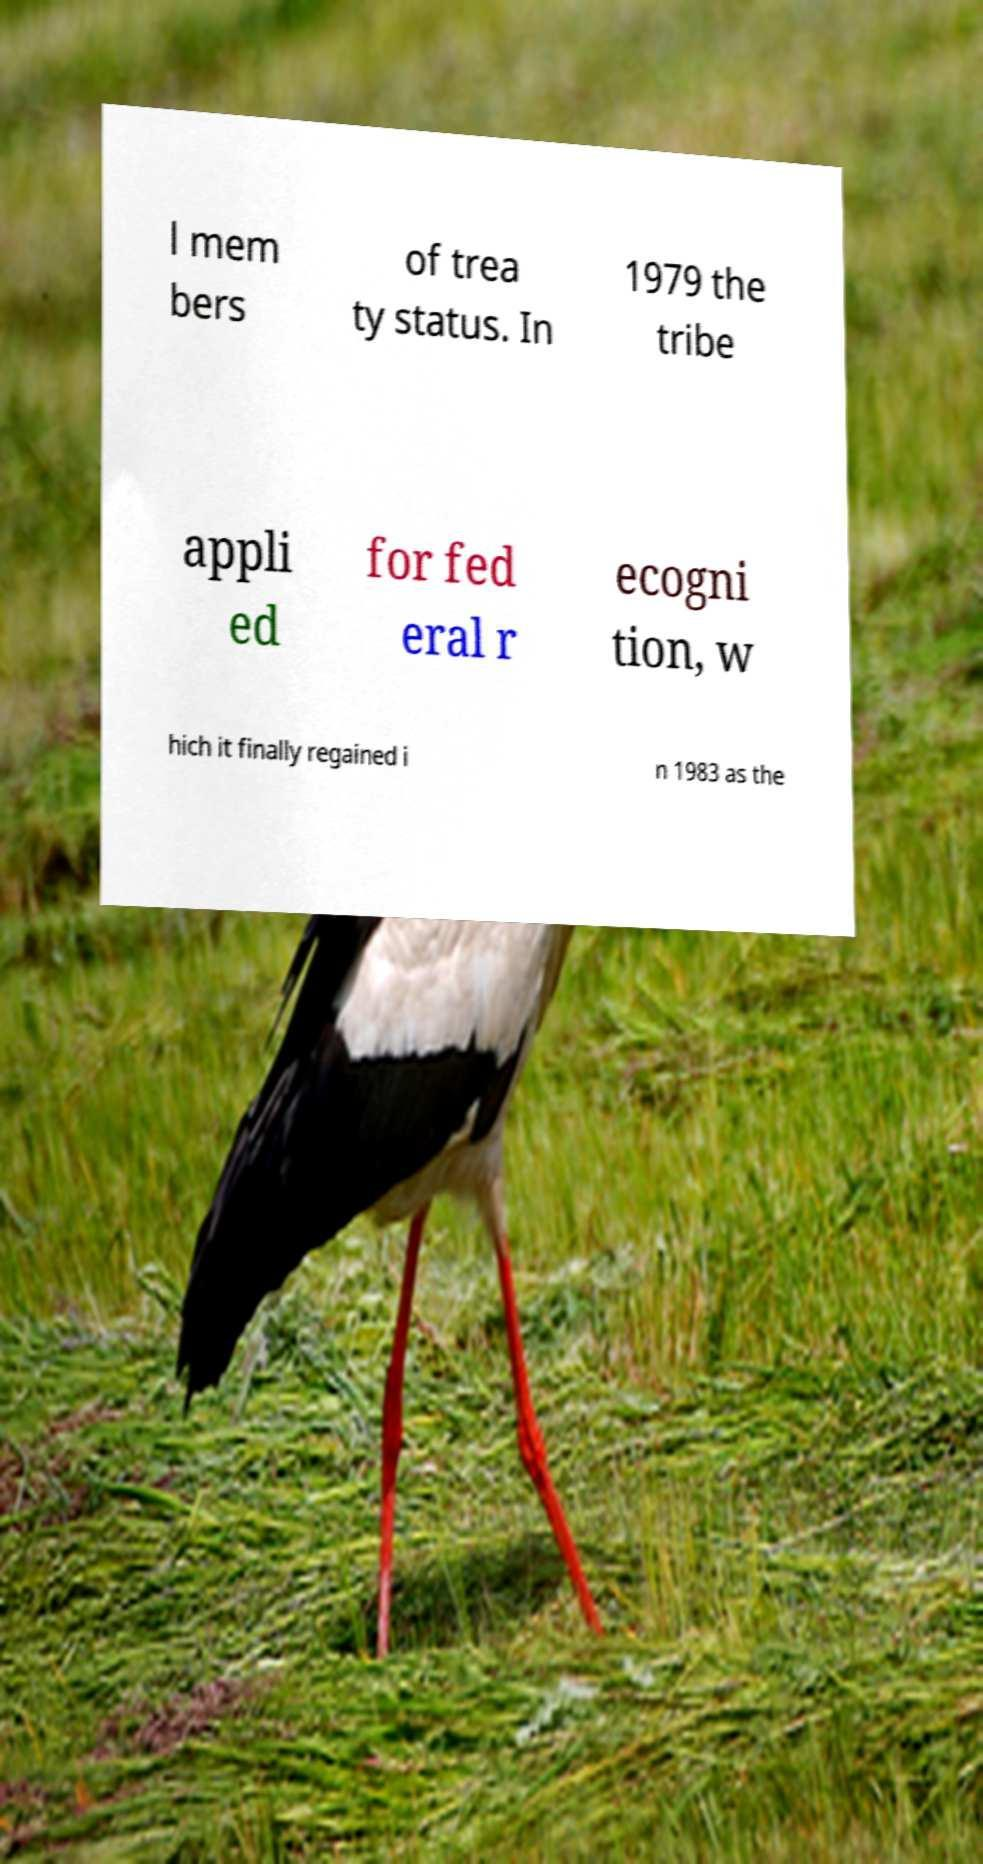Please read and relay the text visible in this image. What does it say? l mem bers of trea ty status. In 1979 the tribe appli ed for fed eral r ecogni tion, w hich it finally regained i n 1983 as the 